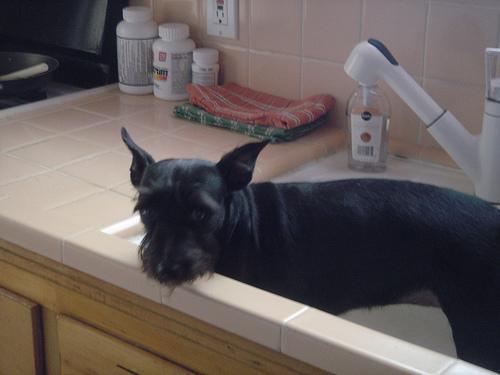How many towels are there?
Give a very brief answer. 2. 